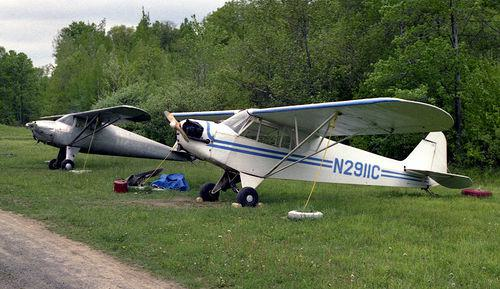How does the presence of these aeroplanes affect the landscape? The aeroplanes add a unique element to the landscape, suggesting human activity in what might otherwise be a natural and rural setting. They bring a sense of technology and transport to the area, possibly indicating a private airstrip or a local airfield nearby. 